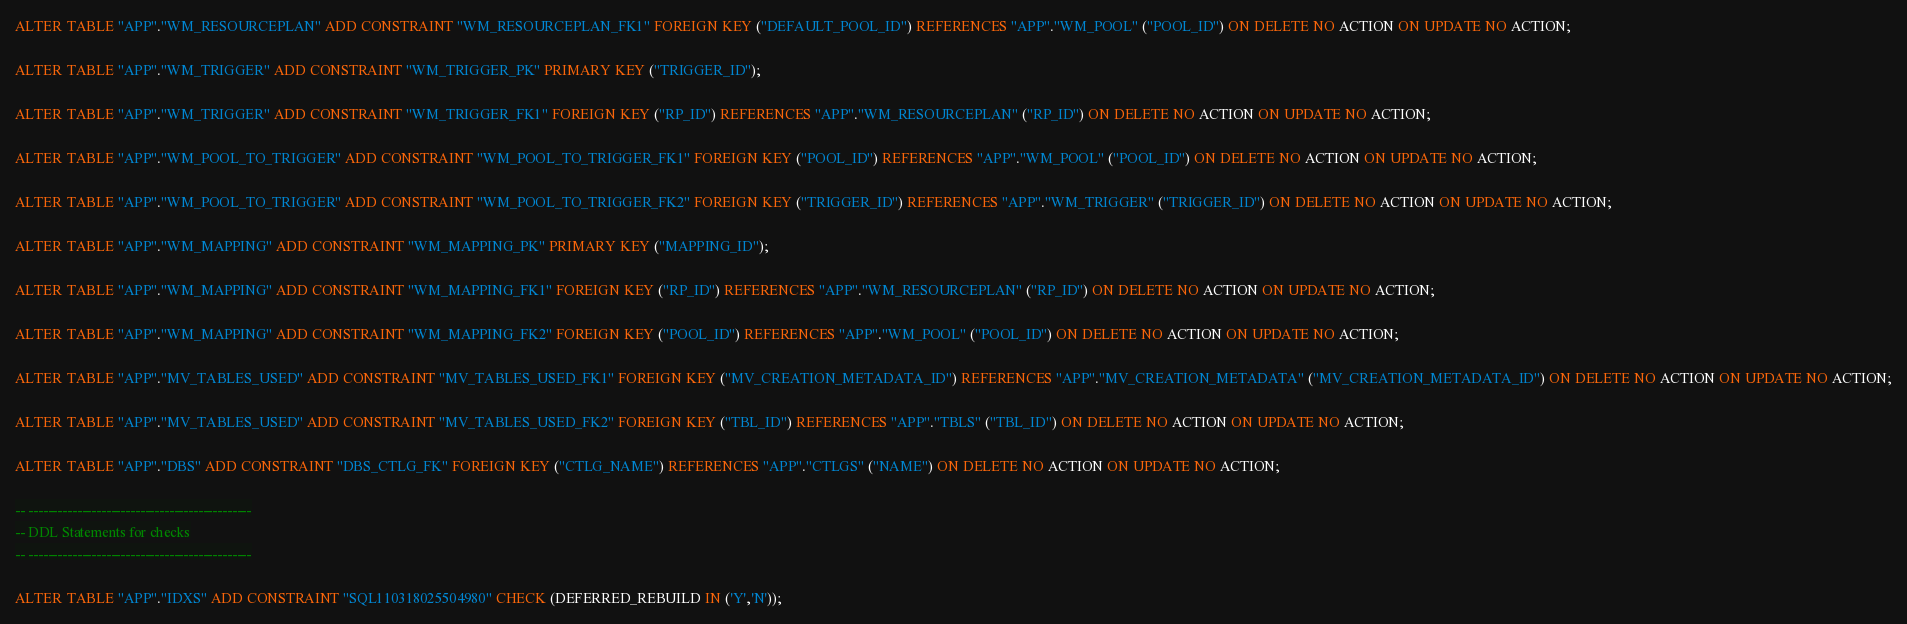Convert code to text. <code><loc_0><loc_0><loc_500><loc_500><_SQL_>ALTER TABLE "APP"."WM_RESOURCEPLAN" ADD CONSTRAINT "WM_RESOURCEPLAN_FK1" FOREIGN KEY ("DEFAULT_POOL_ID") REFERENCES "APP"."WM_POOL" ("POOL_ID") ON DELETE NO ACTION ON UPDATE NO ACTION;

ALTER TABLE "APP"."WM_TRIGGER" ADD CONSTRAINT "WM_TRIGGER_PK" PRIMARY KEY ("TRIGGER_ID");

ALTER TABLE "APP"."WM_TRIGGER" ADD CONSTRAINT "WM_TRIGGER_FK1" FOREIGN KEY ("RP_ID") REFERENCES "APP"."WM_RESOURCEPLAN" ("RP_ID") ON DELETE NO ACTION ON UPDATE NO ACTION;

ALTER TABLE "APP"."WM_POOL_TO_TRIGGER" ADD CONSTRAINT "WM_POOL_TO_TRIGGER_FK1" FOREIGN KEY ("POOL_ID") REFERENCES "APP"."WM_POOL" ("POOL_ID") ON DELETE NO ACTION ON UPDATE NO ACTION;

ALTER TABLE "APP"."WM_POOL_TO_TRIGGER" ADD CONSTRAINT "WM_POOL_TO_TRIGGER_FK2" FOREIGN KEY ("TRIGGER_ID") REFERENCES "APP"."WM_TRIGGER" ("TRIGGER_ID") ON DELETE NO ACTION ON UPDATE NO ACTION;

ALTER TABLE "APP"."WM_MAPPING" ADD CONSTRAINT "WM_MAPPING_PK" PRIMARY KEY ("MAPPING_ID");

ALTER TABLE "APP"."WM_MAPPING" ADD CONSTRAINT "WM_MAPPING_FK1" FOREIGN KEY ("RP_ID") REFERENCES "APP"."WM_RESOURCEPLAN" ("RP_ID") ON DELETE NO ACTION ON UPDATE NO ACTION;

ALTER TABLE "APP"."WM_MAPPING" ADD CONSTRAINT "WM_MAPPING_FK2" FOREIGN KEY ("POOL_ID") REFERENCES "APP"."WM_POOL" ("POOL_ID") ON DELETE NO ACTION ON UPDATE NO ACTION;

ALTER TABLE "APP"."MV_TABLES_USED" ADD CONSTRAINT "MV_TABLES_USED_FK1" FOREIGN KEY ("MV_CREATION_METADATA_ID") REFERENCES "APP"."MV_CREATION_METADATA" ("MV_CREATION_METADATA_ID") ON DELETE NO ACTION ON UPDATE NO ACTION;

ALTER TABLE "APP"."MV_TABLES_USED" ADD CONSTRAINT "MV_TABLES_USED_FK2" FOREIGN KEY ("TBL_ID") REFERENCES "APP"."TBLS" ("TBL_ID") ON DELETE NO ACTION ON UPDATE NO ACTION;

ALTER TABLE "APP"."DBS" ADD CONSTRAINT "DBS_CTLG_FK" FOREIGN KEY ("CTLG_NAME") REFERENCES "APP"."CTLGS" ("NAME") ON DELETE NO ACTION ON UPDATE NO ACTION;

-- ----------------------------------------------
-- DDL Statements for checks
-- ----------------------------------------------

ALTER TABLE "APP"."IDXS" ADD CONSTRAINT "SQL110318025504980" CHECK (DEFERRED_REBUILD IN ('Y','N'));
</code> 